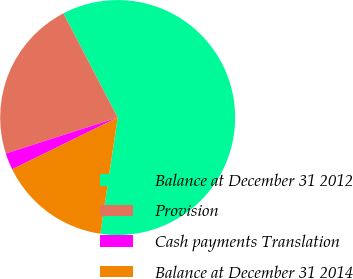<chart> <loc_0><loc_0><loc_500><loc_500><pie_chart><fcel>Balance at December 31 2012<fcel>Provision<fcel>Cash payments Translation<fcel>Balance at December 31 2014<nl><fcel>60.0%<fcel>22.31%<fcel>2.31%<fcel>15.38%<nl></chart> 